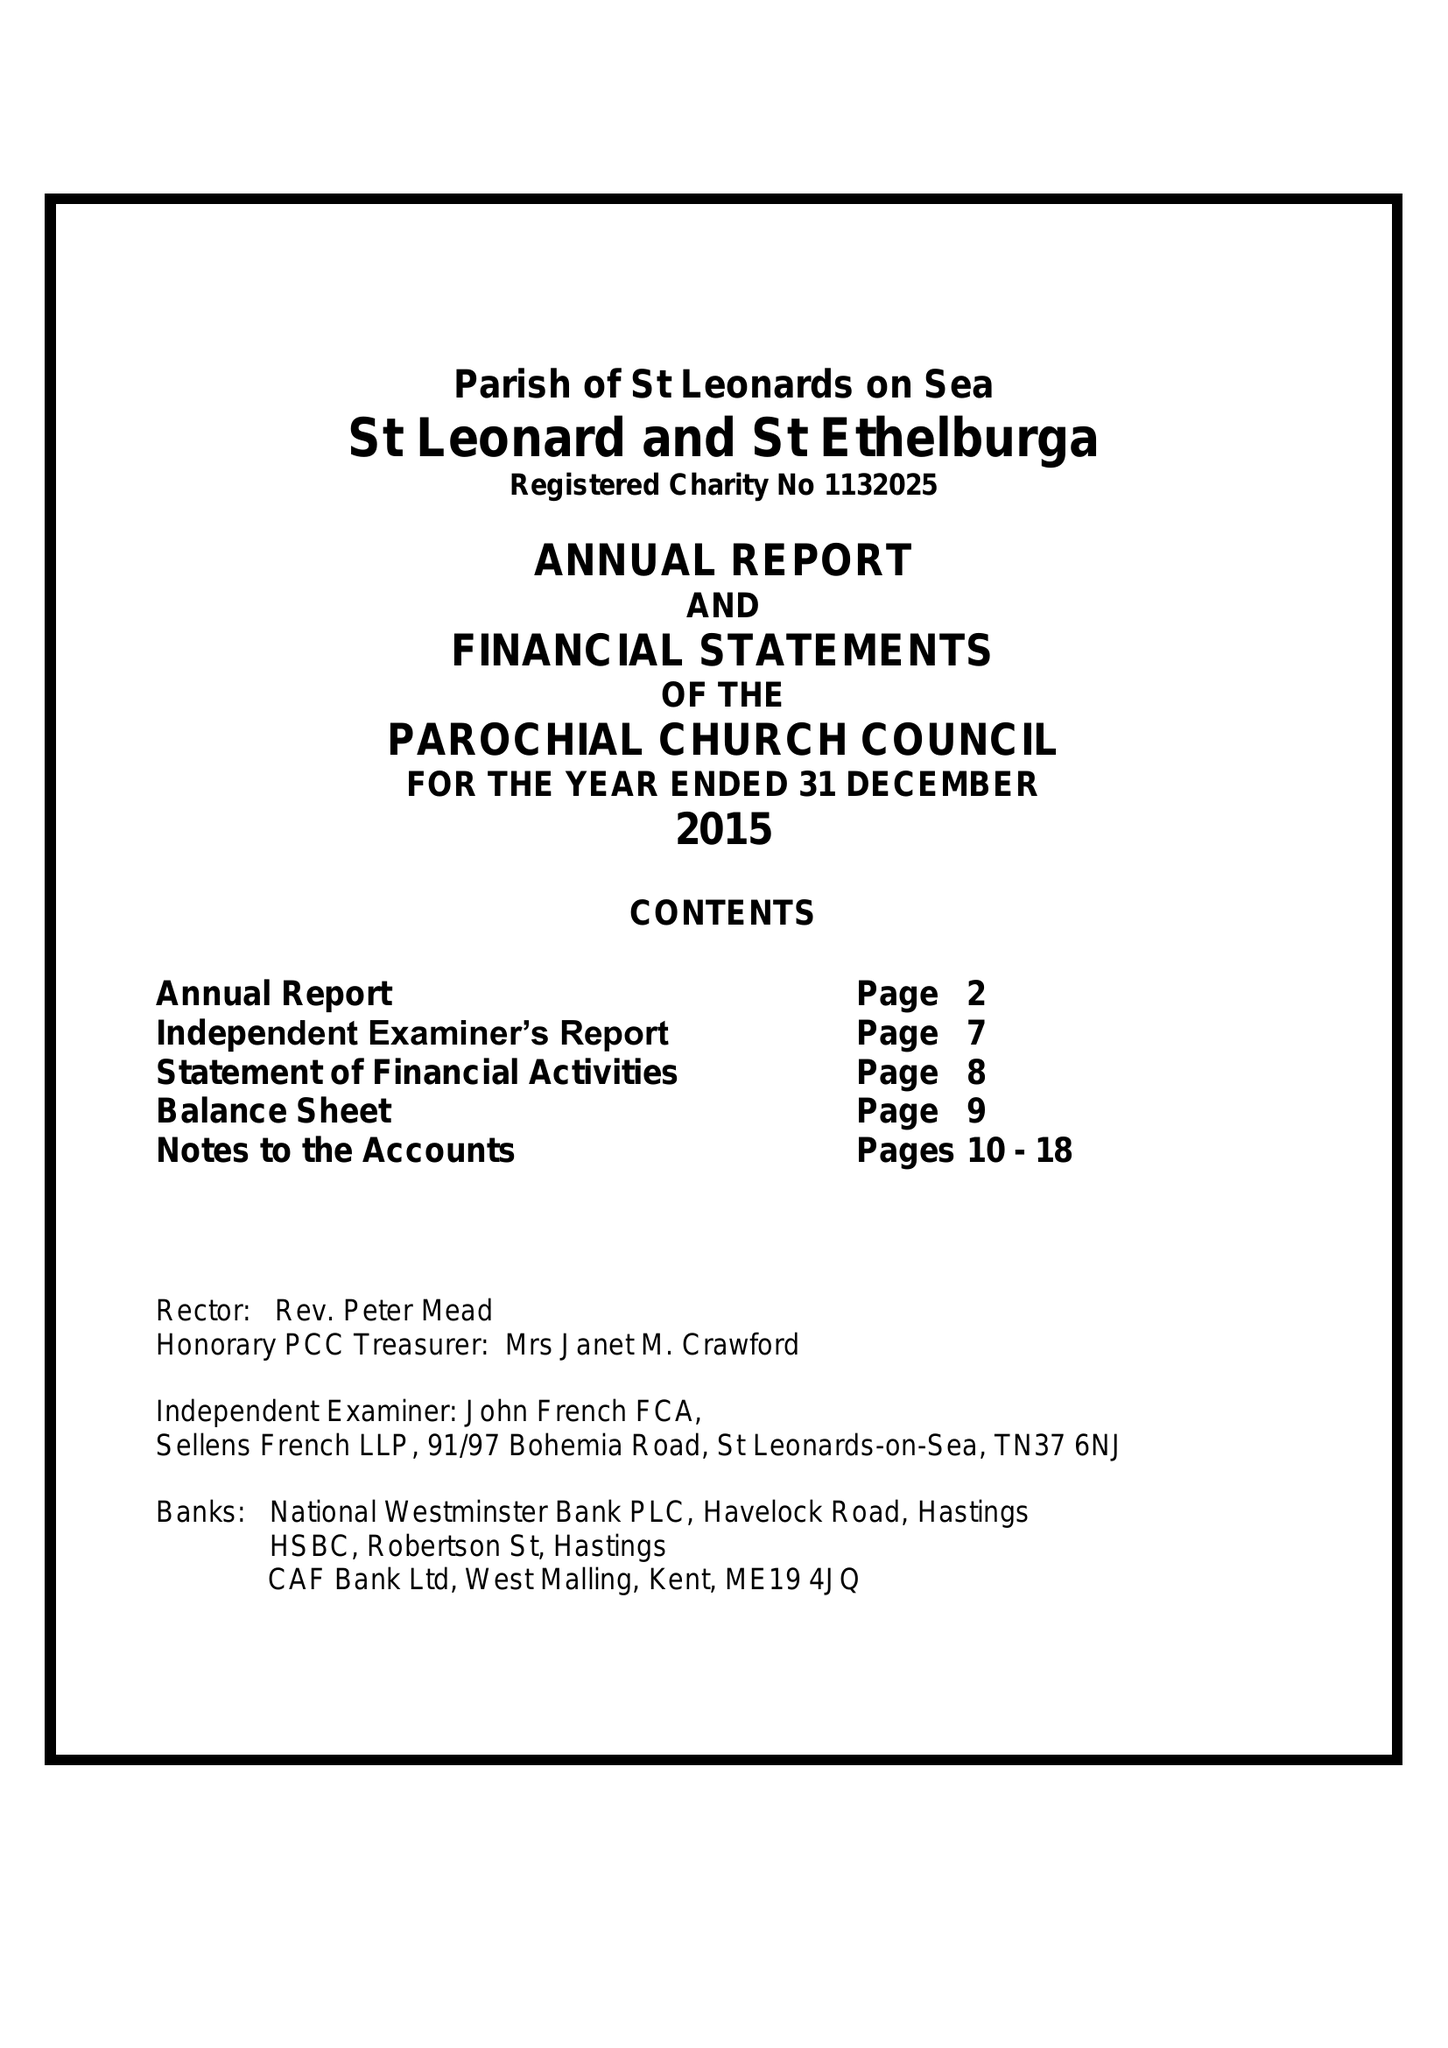What is the value for the address__postcode?
Answer the question using a single word or phrase. TN38 0YW 